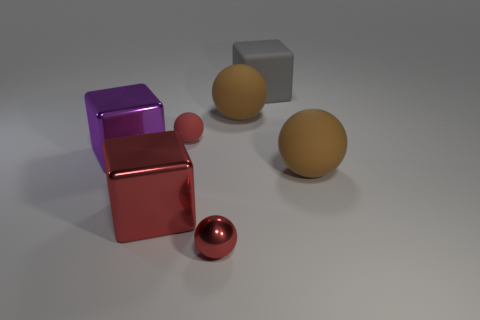Add 1 tiny objects. How many objects exist? 8 Subtract all spheres. How many objects are left? 3 Add 7 cubes. How many cubes are left? 10 Add 3 brown things. How many brown things exist? 5 Subtract 1 red cubes. How many objects are left? 6 Subtract all big red objects. Subtract all big matte objects. How many objects are left? 3 